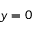Convert formula to latex. <formula><loc_0><loc_0><loc_500><loc_500>y = 0</formula> 